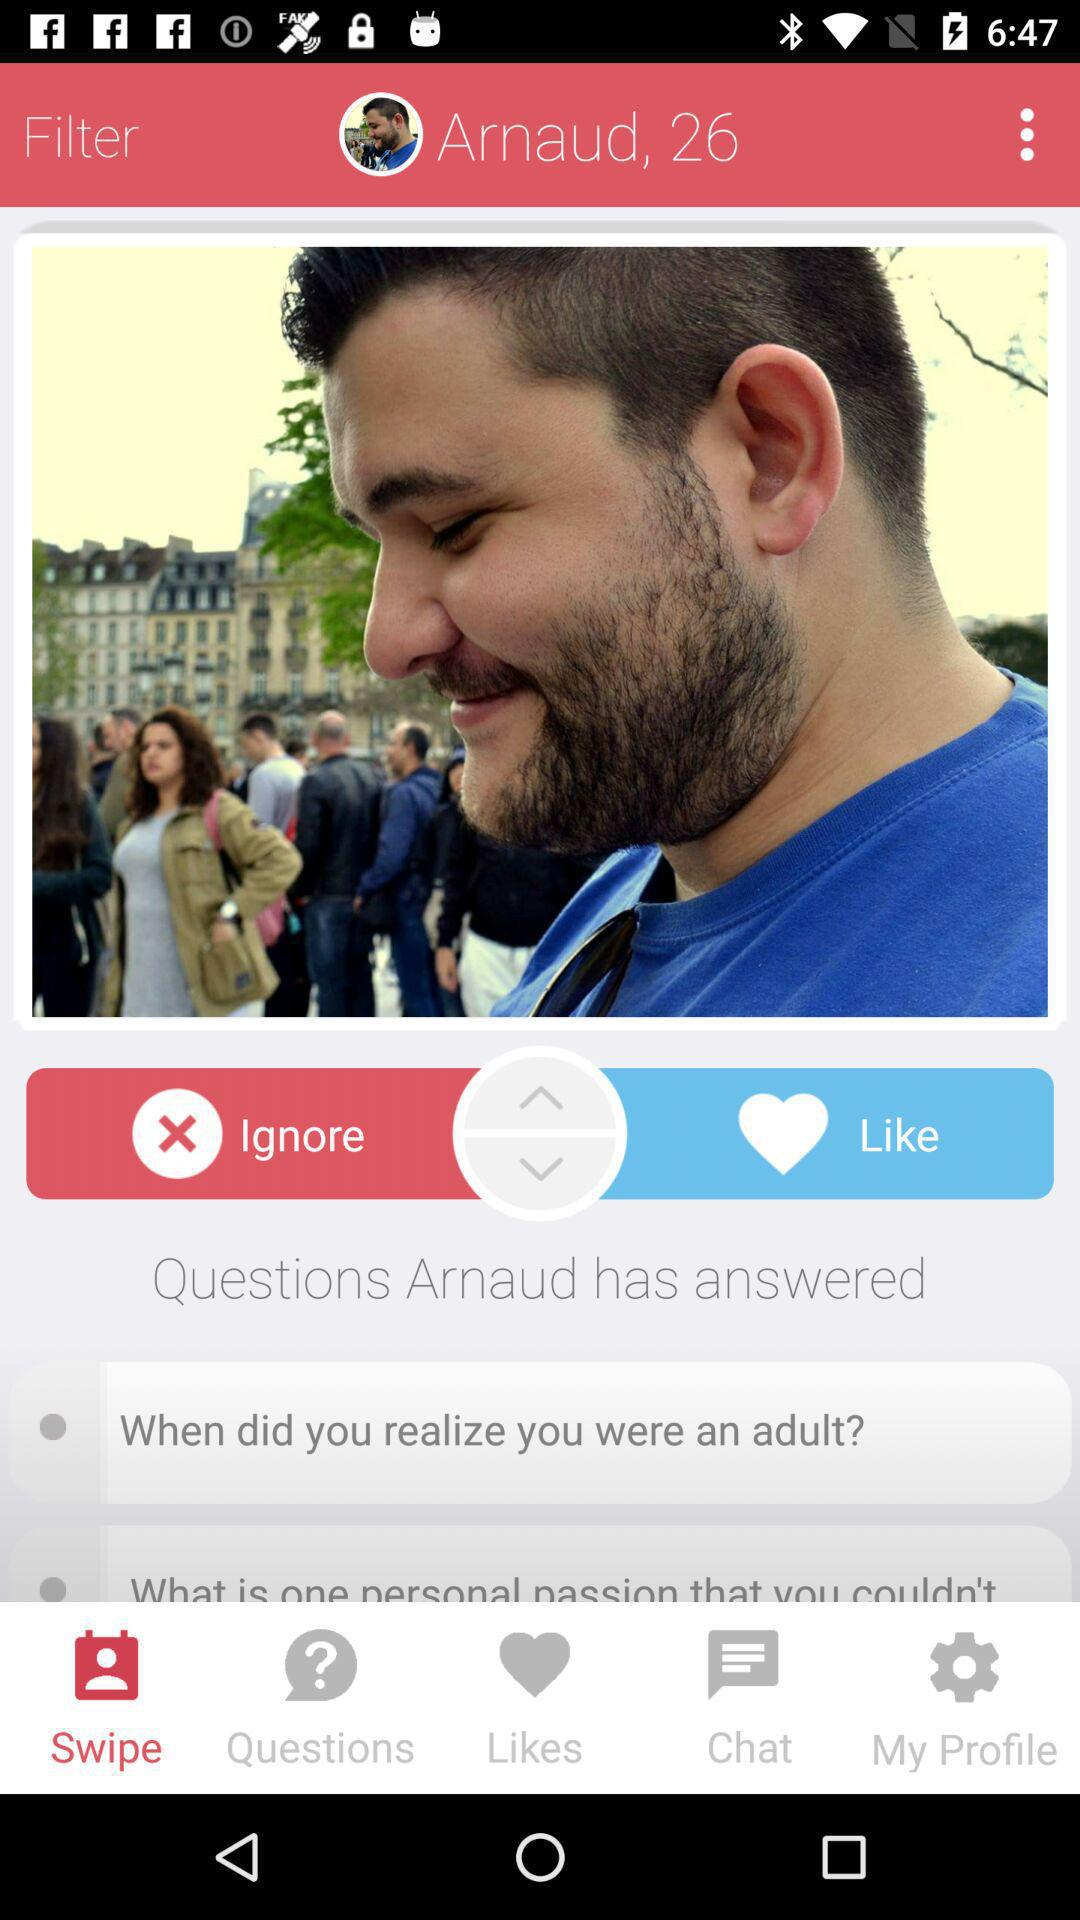What is the age of the user? The user is 26 years old. 